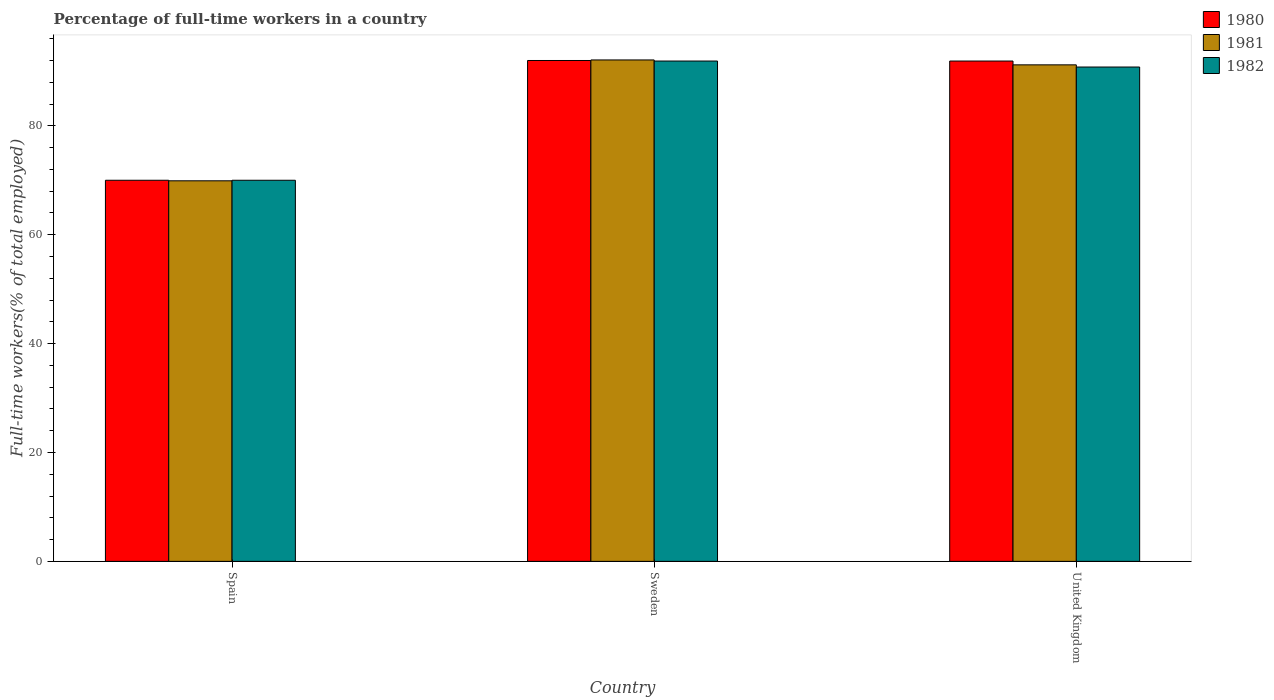How many different coloured bars are there?
Offer a terse response. 3. How many groups of bars are there?
Provide a succinct answer. 3. Are the number of bars per tick equal to the number of legend labels?
Offer a very short reply. Yes. What is the percentage of full-time workers in 1981 in Sweden?
Make the answer very short. 92.1. Across all countries, what is the maximum percentage of full-time workers in 1982?
Offer a very short reply. 91.9. In which country was the percentage of full-time workers in 1982 maximum?
Give a very brief answer. Sweden. What is the total percentage of full-time workers in 1981 in the graph?
Make the answer very short. 253.2. What is the difference between the percentage of full-time workers in 1981 in Spain and that in Sweden?
Provide a short and direct response. -22.2. What is the difference between the percentage of full-time workers in 1982 in Spain and the percentage of full-time workers in 1980 in Sweden?
Keep it short and to the point. -22. What is the average percentage of full-time workers in 1980 per country?
Provide a succinct answer. 84.63. What is the difference between the percentage of full-time workers of/in 1980 and percentage of full-time workers of/in 1981 in Spain?
Ensure brevity in your answer.  0.1. In how many countries, is the percentage of full-time workers in 1981 greater than 48 %?
Your response must be concise. 3. What is the ratio of the percentage of full-time workers in 1982 in Spain to that in Sweden?
Make the answer very short. 0.76. Is the percentage of full-time workers in 1981 in Spain less than that in United Kingdom?
Your response must be concise. Yes. What is the difference between the highest and the second highest percentage of full-time workers in 1982?
Ensure brevity in your answer.  -1.1. What is the difference between the highest and the lowest percentage of full-time workers in 1981?
Provide a short and direct response. 22.2. In how many countries, is the percentage of full-time workers in 1981 greater than the average percentage of full-time workers in 1981 taken over all countries?
Make the answer very short. 2. Is the sum of the percentage of full-time workers in 1981 in Spain and United Kingdom greater than the maximum percentage of full-time workers in 1982 across all countries?
Your answer should be very brief. Yes. Is it the case that in every country, the sum of the percentage of full-time workers in 1981 and percentage of full-time workers in 1980 is greater than the percentage of full-time workers in 1982?
Provide a succinct answer. Yes. Are all the bars in the graph horizontal?
Make the answer very short. No. What is the difference between two consecutive major ticks on the Y-axis?
Your response must be concise. 20. Does the graph contain any zero values?
Make the answer very short. No. Does the graph contain grids?
Your response must be concise. No. How many legend labels are there?
Offer a terse response. 3. What is the title of the graph?
Your response must be concise. Percentage of full-time workers in a country. Does "1982" appear as one of the legend labels in the graph?
Make the answer very short. Yes. What is the label or title of the Y-axis?
Your response must be concise. Full-time workers(% of total employed). What is the Full-time workers(% of total employed) in 1981 in Spain?
Your answer should be very brief. 69.9. What is the Full-time workers(% of total employed) of 1982 in Spain?
Your response must be concise. 70. What is the Full-time workers(% of total employed) of 1980 in Sweden?
Keep it short and to the point. 92. What is the Full-time workers(% of total employed) in 1981 in Sweden?
Provide a succinct answer. 92.1. What is the Full-time workers(% of total employed) in 1982 in Sweden?
Your answer should be compact. 91.9. What is the Full-time workers(% of total employed) of 1980 in United Kingdom?
Make the answer very short. 91.9. What is the Full-time workers(% of total employed) in 1981 in United Kingdom?
Your answer should be compact. 91.2. What is the Full-time workers(% of total employed) of 1982 in United Kingdom?
Ensure brevity in your answer.  90.8. Across all countries, what is the maximum Full-time workers(% of total employed) of 1980?
Provide a short and direct response. 92. Across all countries, what is the maximum Full-time workers(% of total employed) of 1981?
Your answer should be compact. 92.1. Across all countries, what is the maximum Full-time workers(% of total employed) of 1982?
Offer a terse response. 91.9. Across all countries, what is the minimum Full-time workers(% of total employed) in 1981?
Keep it short and to the point. 69.9. What is the total Full-time workers(% of total employed) in 1980 in the graph?
Offer a terse response. 253.9. What is the total Full-time workers(% of total employed) in 1981 in the graph?
Provide a short and direct response. 253.2. What is the total Full-time workers(% of total employed) of 1982 in the graph?
Offer a very short reply. 252.7. What is the difference between the Full-time workers(% of total employed) of 1980 in Spain and that in Sweden?
Ensure brevity in your answer.  -22. What is the difference between the Full-time workers(% of total employed) of 1981 in Spain and that in Sweden?
Provide a short and direct response. -22.2. What is the difference between the Full-time workers(% of total employed) of 1982 in Spain and that in Sweden?
Make the answer very short. -21.9. What is the difference between the Full-time workers(% of total employed) in 1980 in Spain and that in United Kingdom?
Ensure brevity in your answer.  -21.9. What is the difference between the Full-time workers(% of total employed) in 1981 in Spain and that in United Kingdom?
Provide a short and direct response. -21.3. What is the difference between the Full-time workers(% of total employed) in 1982 in Spain and that in United Kingdom?
Your response must be concise. -20.8. What is the difference between the Full-time workers(% of total employed) of 1981 in Sweden and that in United Kingdom?
Ensure brevity in your answer.  0.9. What is the difference between the Full-time workers(% of total employed) in 1980 in Spain and the Full-time workers(% of total employed) in 1981 in Sweden?
Provide a short and direct response. -22.1. What is the difference between the Full-time workers(% of total employed) in 1980 in Spain and the Full-time workers(% of total employed) in 1982 in Sweden?
Your answer should be compact. -21.9. What is the difference between the Full-time workers(% of total employed) of 1981 in Spain and the Full-time workers(% of total employed) of 1982 in Sweden?
Your answer should be very brief. -22. What is the difference between the Full-time workers(% of total employed) of 1980 in Spain and the Full-time workers(% of total employed) of 1981 in United Kingdom?
Offer a very short reply. -21.2. What is the difference between the Full-time workers(% of total employed) in 1980 in Spain and the Full-time workers(% of total employed) in 1982 in United Kingdom?
Provide a short and direct response. -20.8. What is the difference between the Full-time workers(% of total employed) in 1981 in Spain and the Full-time workers(% of total employed) in 1982 in United Kingdom?
Provide a succinct answer. -20.9. What is the difference between the Full-time workers(% of total employed) in 1980 in Sweden and the Full-time workers(% of total employed) in 1982 in United Kingdom?
Your response must be concise. 1.2. What is the average Full-time workers(% of total employed) in 1980 per country?
Give a very brief answer. 84.63. What is the average Full-time workers(% of total employed) in 1981 per country?
Your answer should be compact. 84.4. What is the average Full-time workers(% of total employed) in 1982 per country?
Provide a short and direct response. 84.23. What is the difference between the Full-time workers(% of total employed) in 1980 and Full-time workers(% of total employed) in 1981 in Spain?
Offer a very short reply. 0.1. What is the difference between the Full-time workers(% of total employed) of 1980 and Full-time workers(% of total employed) of 1981 in Sweden?
Offer a very short reply. -0.1. What is the difference between the Full-time workers(% of total employed) of 1980 and Full-time workers(% of total employed) of 1982 in Sweden?
Your response must be concise. 0.1. What is the difference between the Full-time workers(% of total employed) in 1981 and Full-time workers(% of total employed) in 1982 in Sweden?
Your answer should be compact. 0.2. What is the difference between the Full-time workers(% of total employed) of 1981 and Full-time workers(% of total employed) of 1982 in United Kingdom?
Provide a short and direct response. 0.4. What is the ratio of the Full-time workers(% of total employed) in 1980 in Spain to that in Sweden?
Provide a succinct answer. 0.76. What is the ratio of the Full-time workers(% of total employed) in 1981 in Spain to that in Sweden?
Give a very brief answer. 0.76. What is the ratio of the Full-time workers(% of total employed) in 1982 in Spain to that in Sweden?
Give a very brief answer. 0.76. What is the ratio of the Full-time workers(% of total employed) of 1980 in Spain to that in United Kingdom?
Your response must be concise. 0.76. What is the ratio of the Full-time workers(% of total employed) in 1981 in Spain to that in United Kingdom?
Your answer should be compact. 0.77. What is the ratio of the Full-time workers(% of total employed) in 1982 in Spain to that in United Kingdom?
Offer a very short reply. 0.77. What is the ratio of the Full-time workers(% of total employed) of 1981 in Sweden to that in United Kingdom?
Keep it short and to the point. 1.01. What is the ratio of the Full-time workers(% of total employed) of 1982 in Sweden to that in United Kingdom?
Keep it short and to the point. 1.01. What is the difference between the highest and the second highest Full-time workers(% of total employed) of 1980?
Give a very brief answer. 0.1. What is the difference between the highest and the second highest Full-time workers(% of total employed) in 1982?
Offer a terse response. 1.1. What is the difference between the highest and the lowest Full-time workers(% of total employed) of 1981?
Provide a short and direct response. 22.2. What is the difference between the highest and the lowest Full-time workers(% of total employed) of 1982?
Your response must be concise. 21.9. 